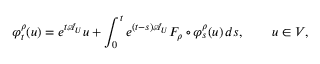<formula> <loc_0><loc_0><loc_500><loc_500>\varphi _ { t } ^ { \rho } ( u ) = e ^ { t \mathcal { A } _ { U } } u + \int _ { 0 } ^ { t } e ^ { ( t - s ) \mathcal { A } _ { U } } F _ { \rho } \circ \varphi _ { s } ^ { \rho } ( u ) \, d s , \quad u \in V ,</formula> 